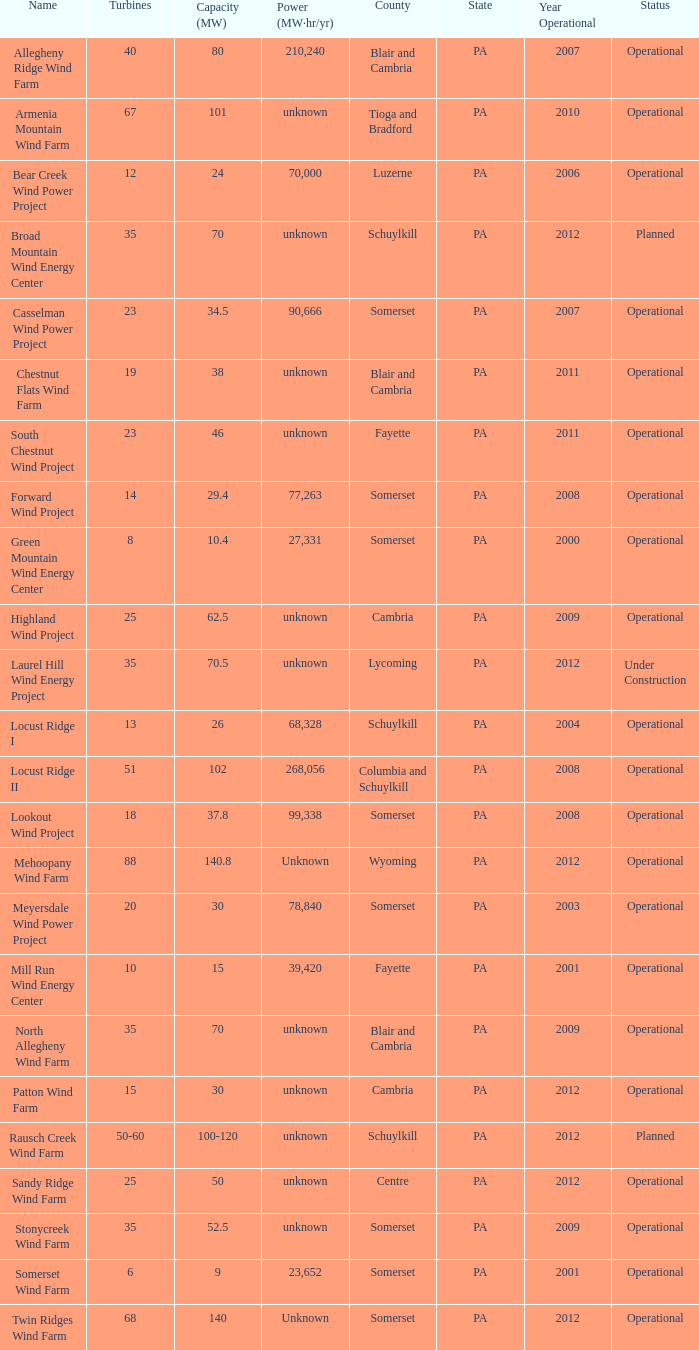What locations are considered centre? Unknown. 